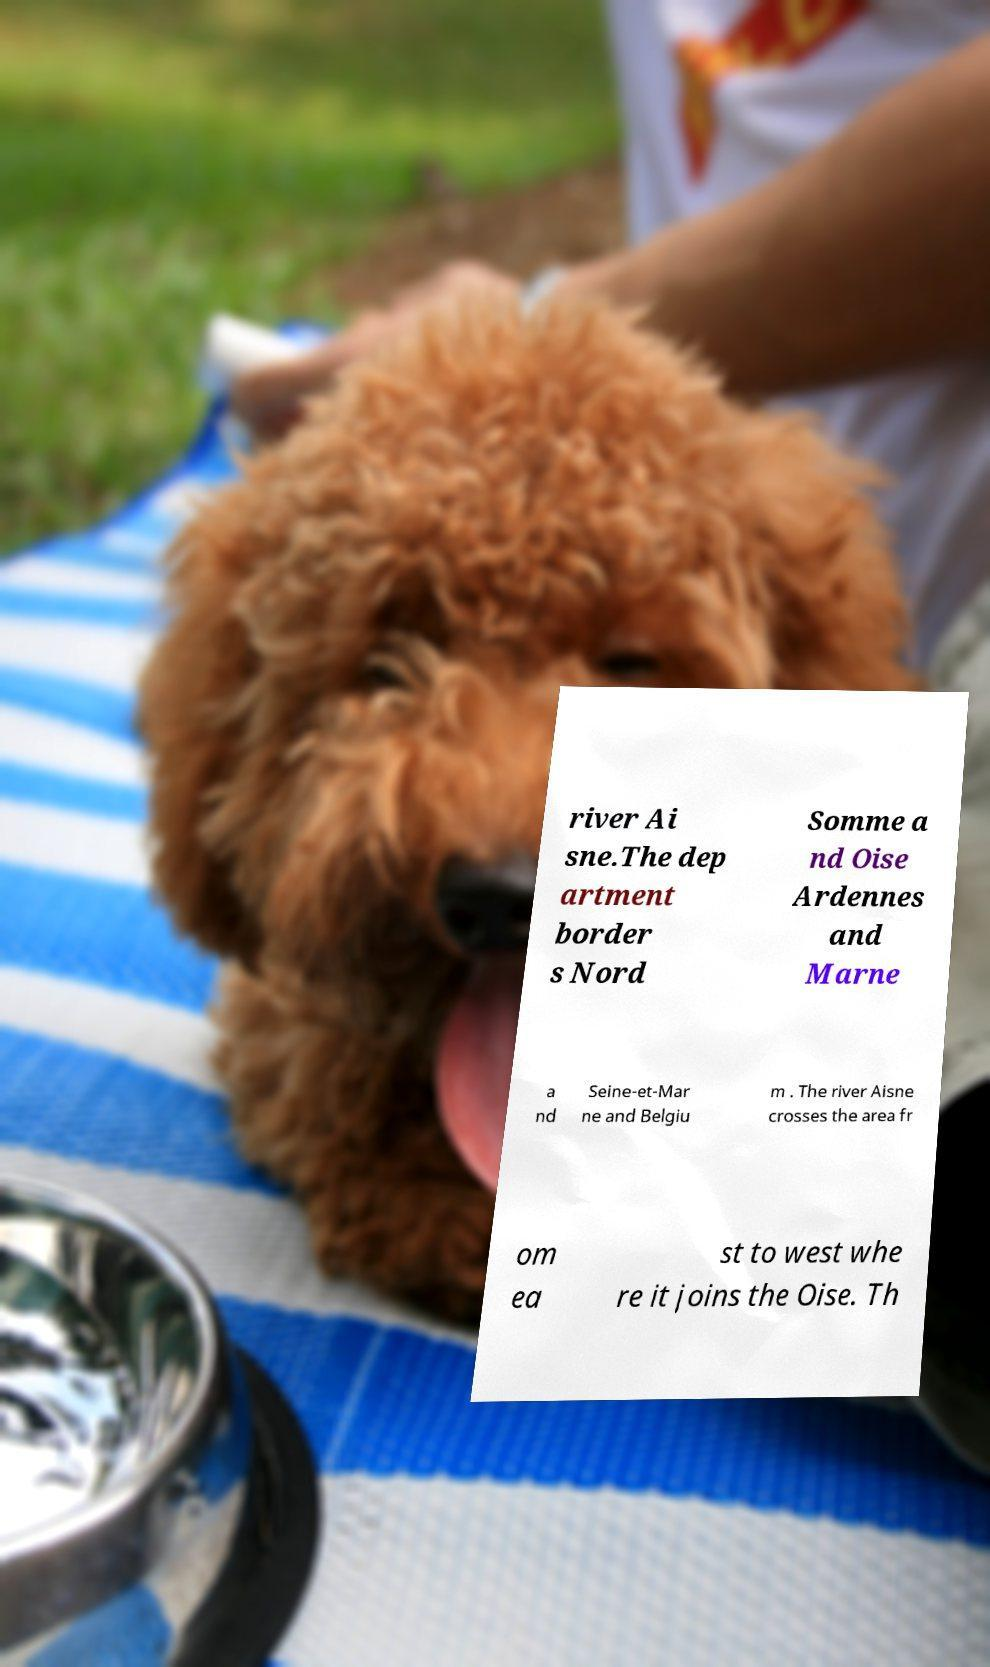Could you extract and type out the text from this image? river Ai sne.The dep artment border s Nord Somme a nd Oise Ardennes and Marne a nd Seine-et-Mar ne and Belgiu m . The river Aisne crosses the area fr om ea st to west whe re it joins the Oise. Th 